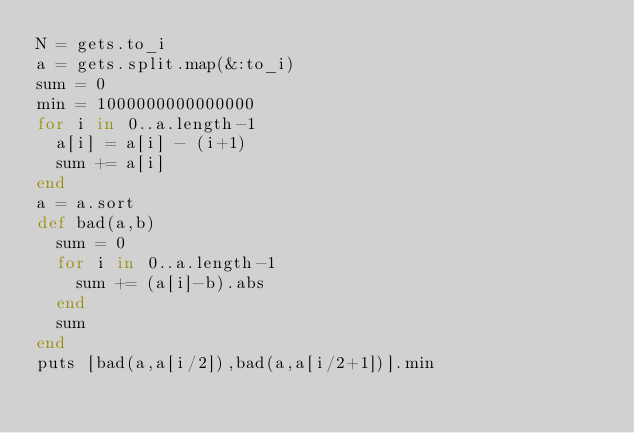<code> <loc_0><loc_0><loc_500><loc_500><_Ruby_>N = gets.to_i
a = gets.split.map(&:to_i)
sum = 0
min = 1000000000000000
for i in 0..a.length-1
  a[i] = a[i] - (i+1)
  sum += a[i]
end
a = a.sort
def bad(a,b)
  sum = 0
  for i in 0..a.length-1
    sum += (a[i]-b).abs
  end
  sum
end
puts [bad(a,a[i/2]),bad(a,a[i/2+1])].min</code> 